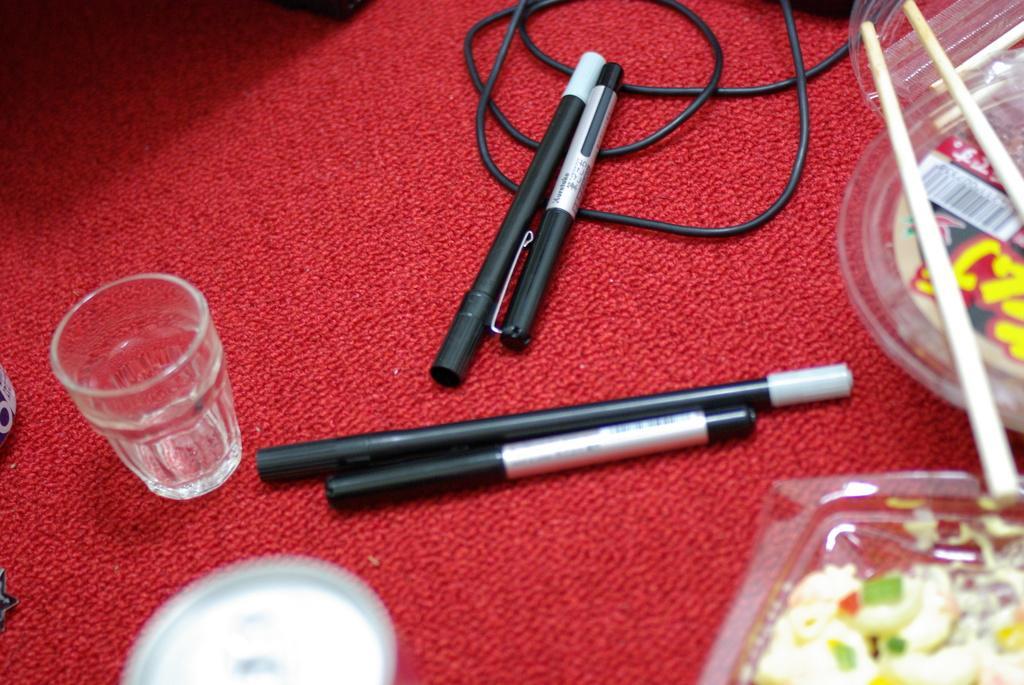Could you give a brief overview of what you see in this image? In this image, we can see pens, a glass, boxes and there are food items and we can see a cable and some other objects are on the mat. 